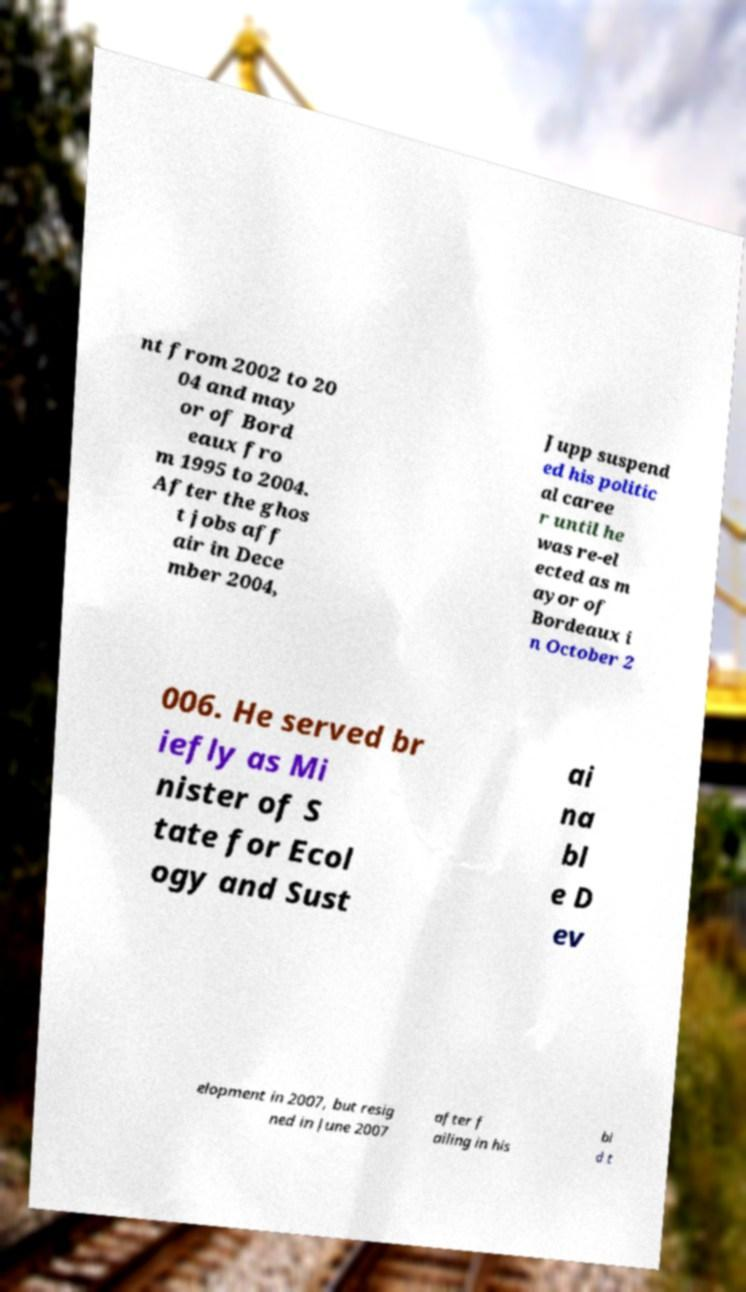Please read and relay the text visible in this image. What does it say? nt from 2002 to 20 04 and may or of Bord eaux fro m 1995 to 2004. After the ghos t jobs aff air in Dece mber 2004, Jupp suspend ed his politic al caree r until he was re-el ected as m ayor of Bordeaux i n October 2 006. He served br iefly as Mi nister of S tate for Ecol ogy and Sust ai na bl e D ev elopment in 2007, but resig ned in June 2007 after f ailing in his bi d t 